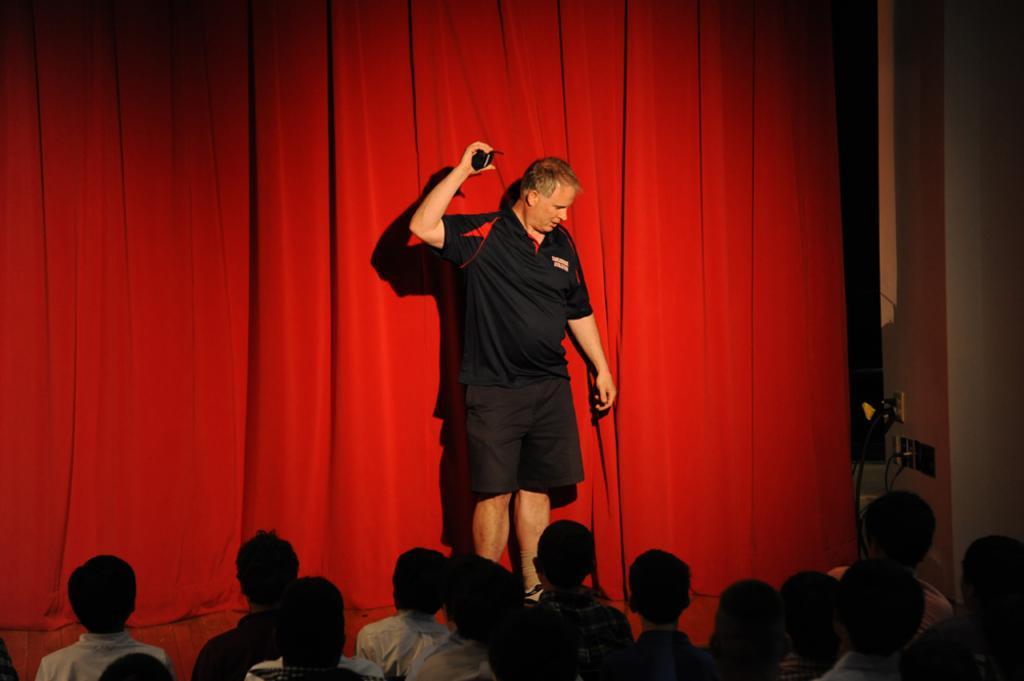How would you summarize this image in a sentence or two? At the bottom of the image we can see a few people. In the center of the image we can see, one person is standing and he is holding some object and he is wearing a black color t shirt. In the background there is a wall, red curtain, wires and a few other objects. 